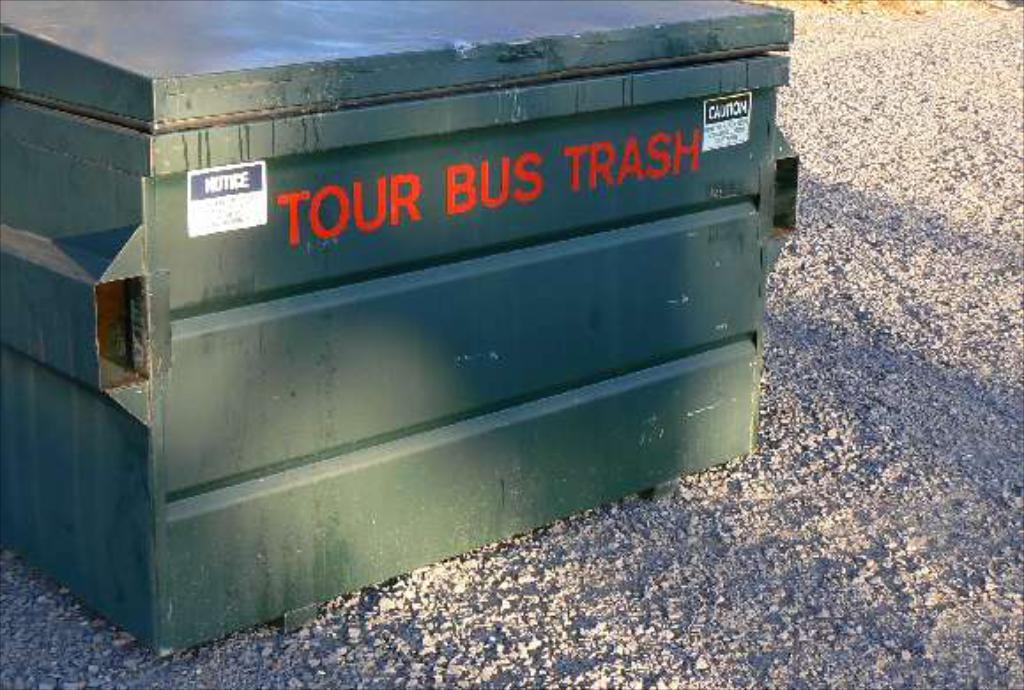<image>
Present a compact description of the photo's key features. A large green bin with the words "Tour bus Trash" on the side in red. 